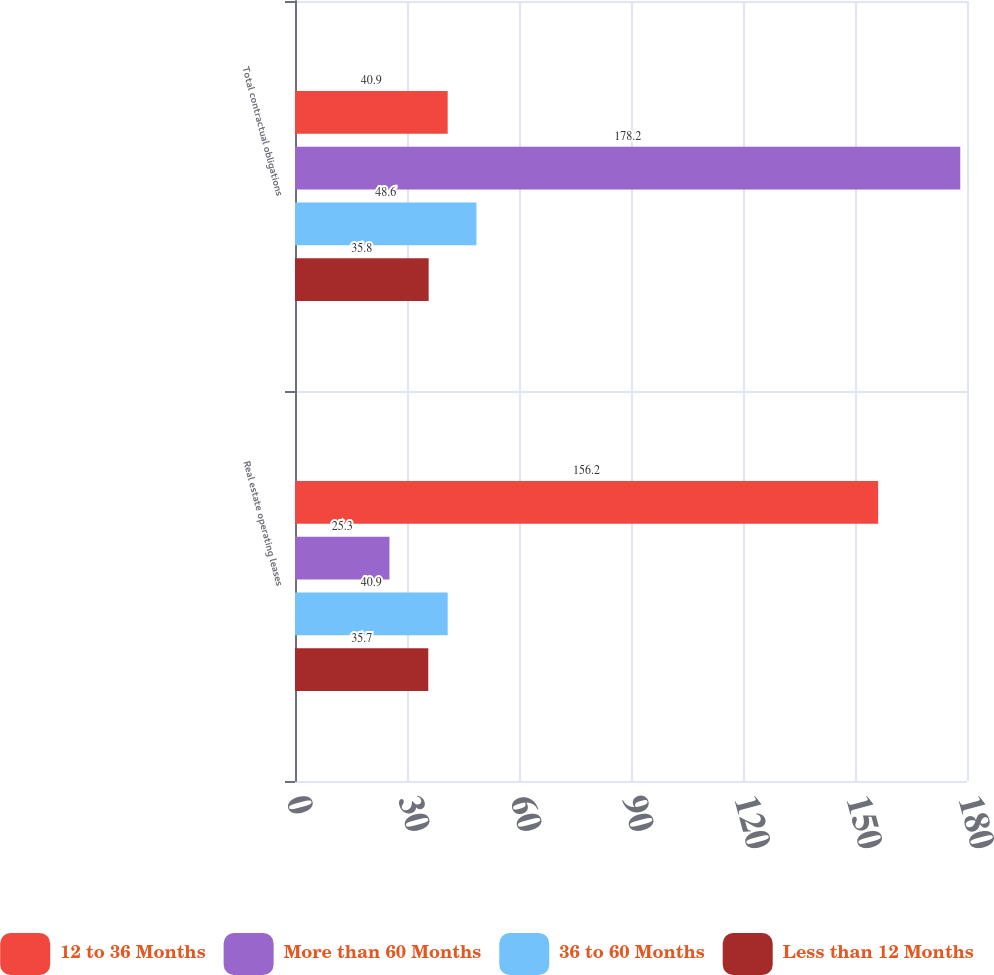Convert chart to OTSL. <chart><loc_0><loc_0><loc_500><loc_500><stacked_bar_chart><ecel><fcel>Real estate operating leases<fcel>Total contractual obligations<nl><fcel>12 to 36 Months<fcel>156.2<fcel>40.9<nl><fcel>More than 60 Months<fcel>25.3<fcel>178.2<nl><fcel>36 to 60 Months<fcel>40.9<fcel>48.6<nl><fcel>Less than 12 Months<fcel>35.7<fcel>35.8<nl></chart> 